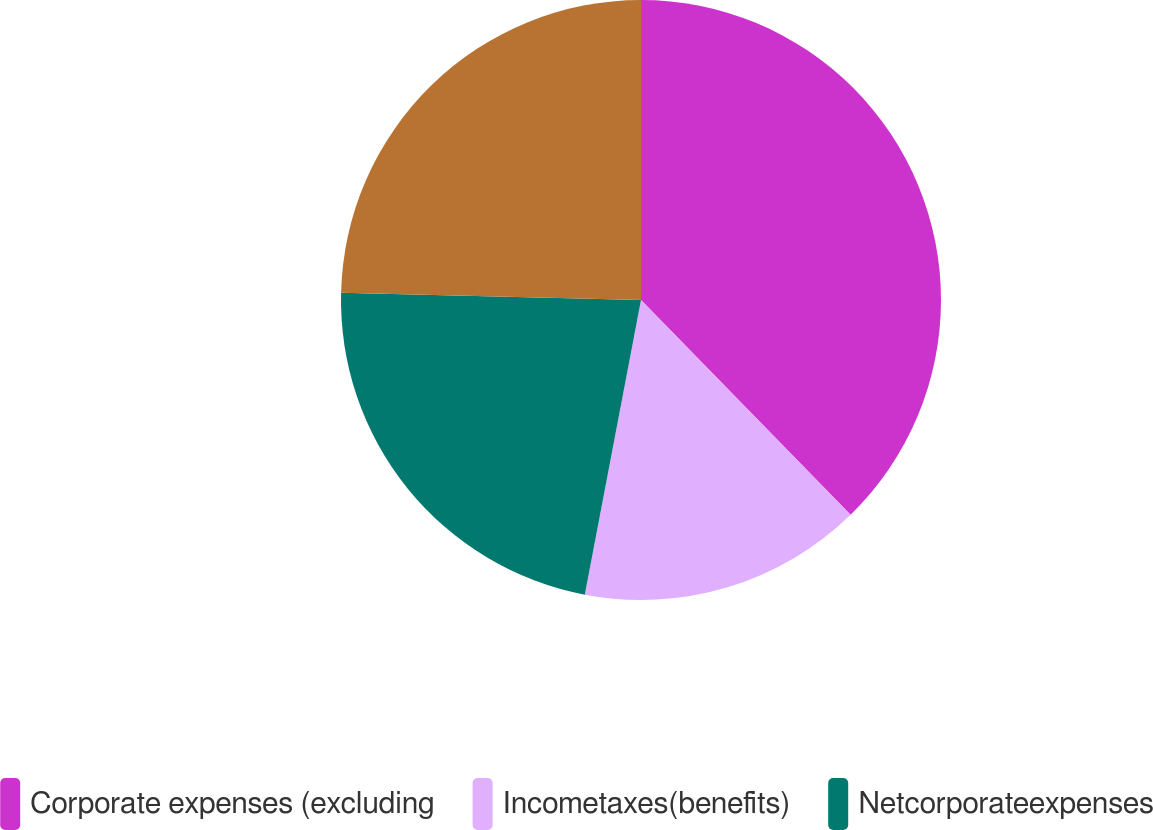Convert chart to OTSL. <chart><loc_0><loc_0><loc_500><loc_500><pie_chart><fcel>Corporate expenses (excluding<fcel>Incometaxes(benefits)<fcel>Netcorporateexpenses<fcel>Unnamed: 3<nl><fcel>37.69%<fcel>15.31%<fcel>22.38%<fcel>24.62%<nl></chart> 